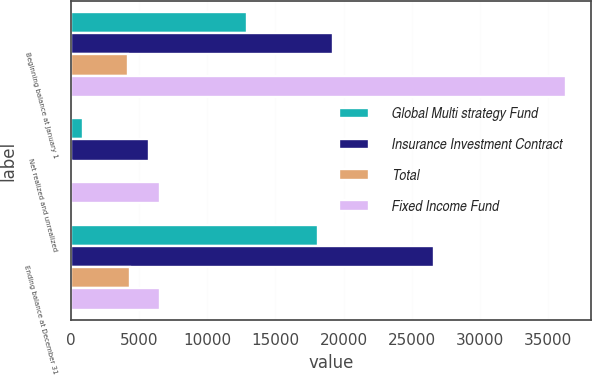Convert chart. <chart><loc_0><loc_0><loc_500><loc_500><stacked_bar_chart><ecel><fcel>Beginning balance at January 1<fcel>Net realized and unrealized<fcel>Ending balance at December 31<nl><fcel>Global Multi strategy Fund<fcel>12881<fcel>866<fcel>18093<nl><fcel>Insurance Investment Contract<fcel>19250<fcel>5750<fcel>26606<nl><fcel>Total<fcel>4173<fcel>109<fcel>4341<nl><fcel>Fixed Income Fund<fcel>36304<fcel>6507<fcel>6507<nl></chart> 